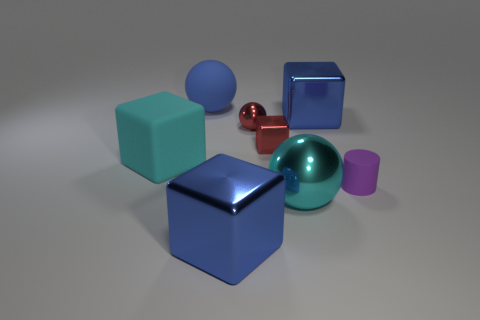Subtract all big cyan blocks. How many blocks are left? 3 Subtract all red blocks. How many blocks are left? 3 Subtract 1 balls. How many balls are left? 2 Subtract all gray blocks. Subtract all green spheres. How many blocks are left? 4 Add 1 small rubber things. How many objects exist? 9 Subtract all cylinders. How many objects are left? 7 Subtract 1 red balls. How many objects are left? 7 Subtract all red shiny objects. Subtract all spheres. How many objects are left? 3 Add 5 purple cylinders. How many purple cylinders are left? 6 Add 6 large shiny things. How many large shiny things exist? 9 